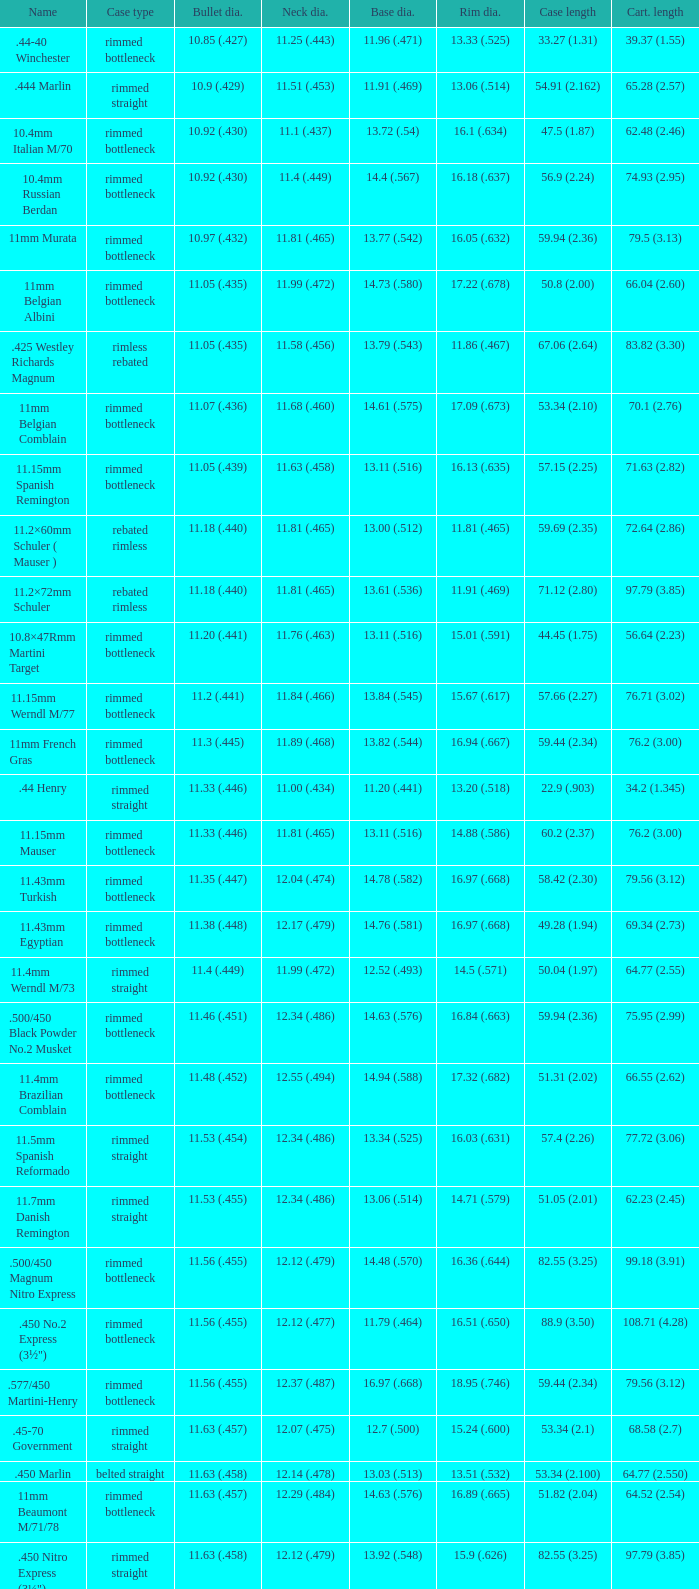Which Rim diameter has a Neck diameter of 11.84 (.466)? 15.67 (.617). 